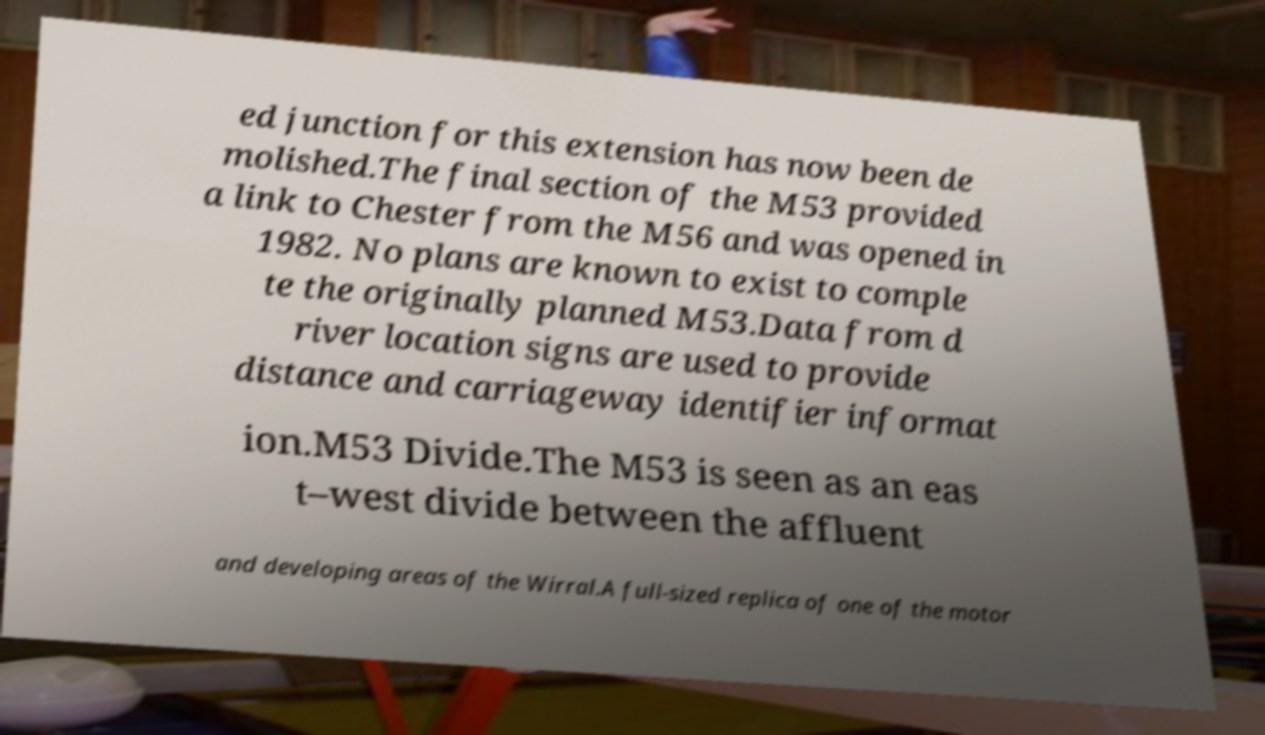Could you assist in decoding the text presented in this image and type it out clearly? ed junction for this extension has now been de molished.The final section of the M53 provided a link to Chester from the M56 and was opened in 1982. No plans are known to exist to comple te the originally planned M53.Data from d river location signs are used to provide distance and carriageway identifier informat ion.M53 Divide.The M53 is seen as an eas t–west divide between the affluent and developing areas of the Wirral.A full-sized replica of one of the motor 